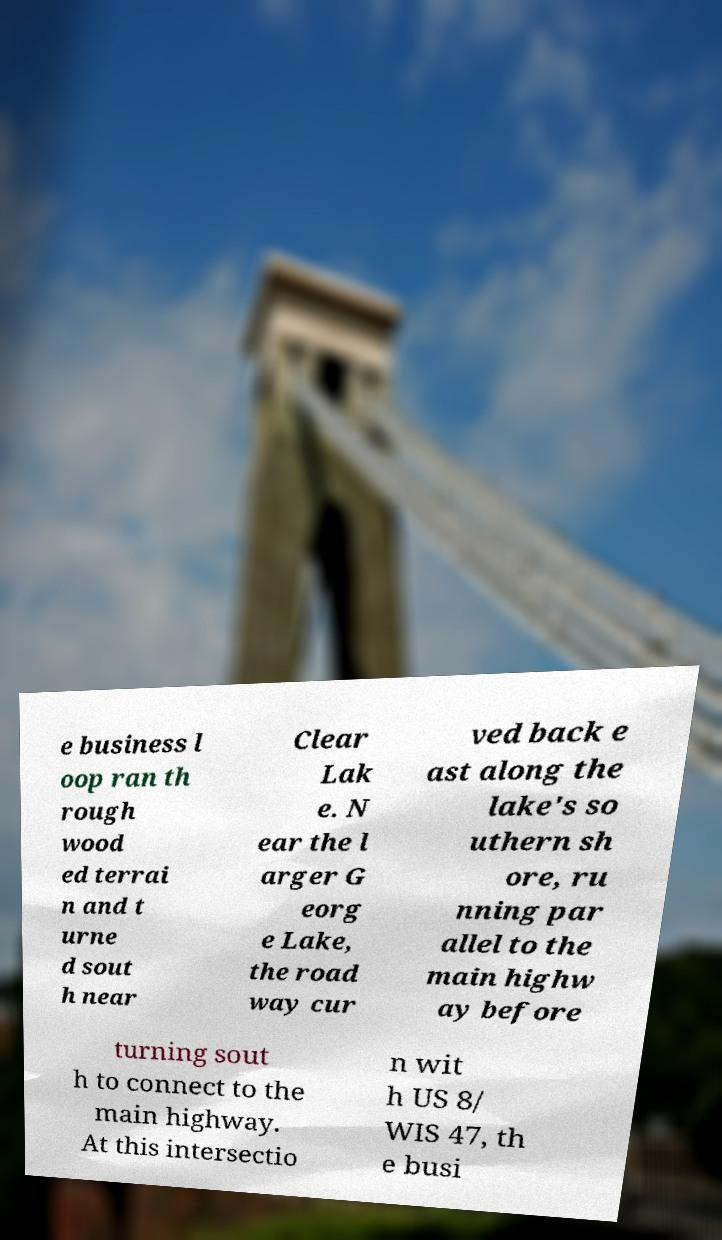For documentation purposes, I need the text within this image transcribed. Could you provide that? e business l oop ran th rough wood ed terrai n and t urne d sout h near Clear Lak e. N ear the l arger G eorg e Lake, the road way cur ved back e ast along the lake's so uthern sh ore, ru nning par allel to the main highw ay before turning sout h to connect to the main highway. At this intersectio n wit h US 8/ WIS 47, th e busi 